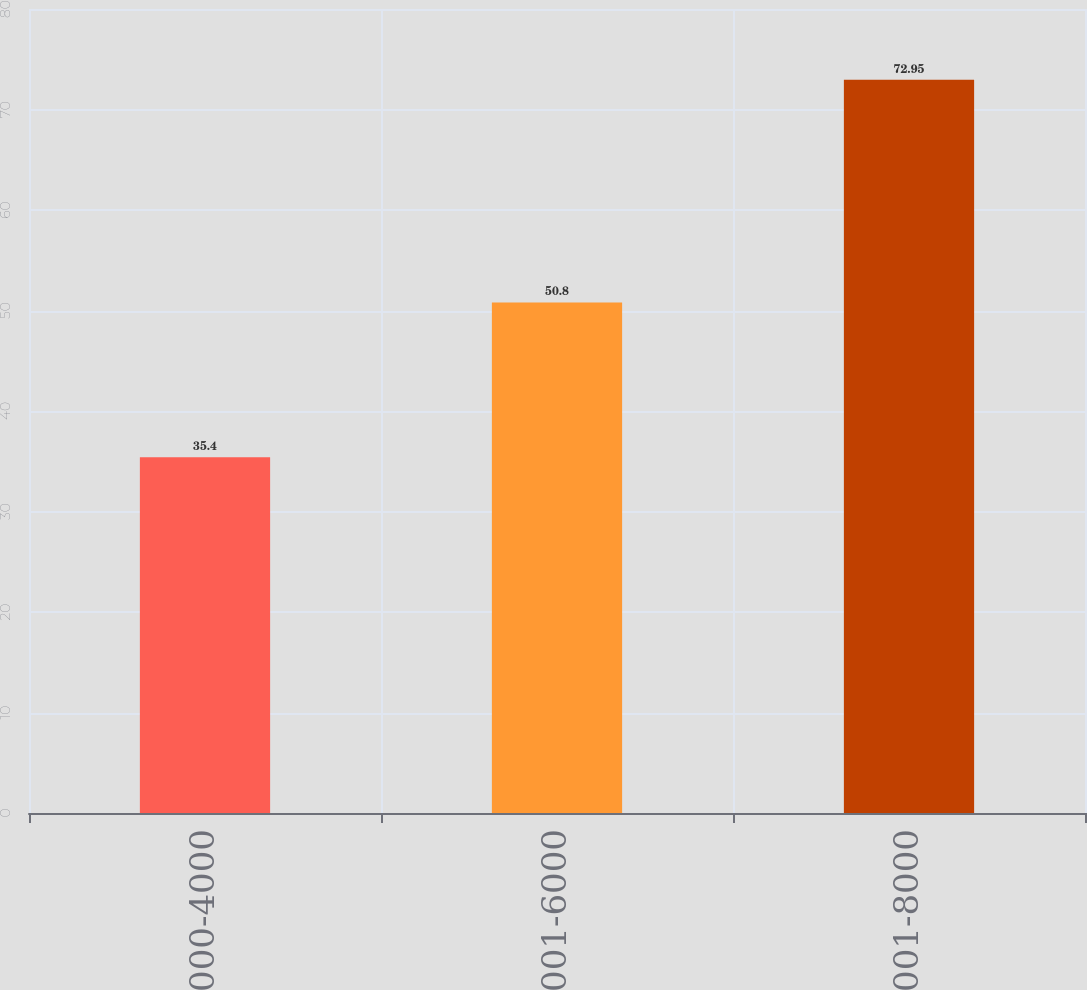Convert chart. <chart><loc_0><loc_0><loc_500><loc_500><bar_chart><fcel>2000-4000<fcel>4001-6000<fcel>6001-8000<nl><fcel>35.4<fcel>50.8<fcel>72.95<nl></chart> 